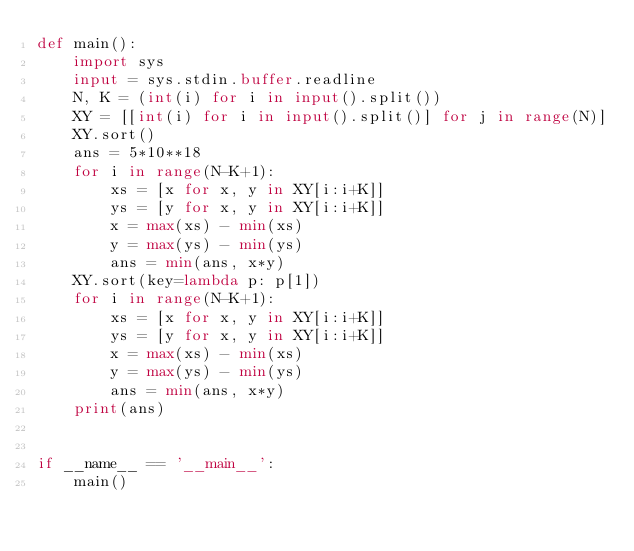<code> <loc_0><loc_0><loc_500><loc_500><_Python_>def main():
    import sys
    input = sys.stdin.buffer.readline
    N, K = (int(i) for i in input().split())
    XY = [[int(i) for i in input().split()] for j in range(N)]
    XY.sort()
    ans = 5*10**18
    for i in range(N-K+1):
        xs = [x for x, y in XY[i:i+K]]
        ys = [y for x, y in XY[i:i+K]]
        x = max(xs) - min(xs)
        y = max(ys) - min(ys)
        ans = min(ans, x*y)
    XY.sort(key=lambda p: p[1])
    for i in range(N-K+1):
        xs = [x for x, y in XY[i:i+K]]
        ys = [y for x, y in XY[i:i+K]]
        x = max(xs) - min(xs)
        y = max(ys) - min(ys)
        ans = min(ans, x*y)
    print(ans)


if __name__ == '__main__':
    main()
</code> 